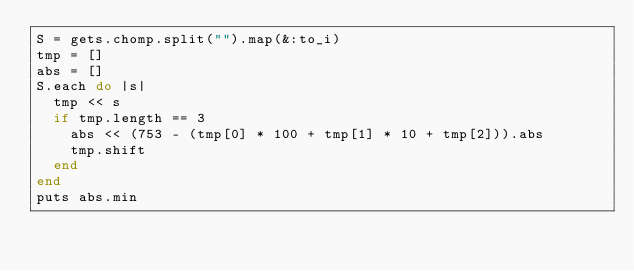Convert code to text. <code><loc_0><loc_0><loc_500><loc_500><_Ruby_>S = gets.chomp.split("").map(&:to_i)
tmp = []
abs = []
S.each do |s|
  tmp << s
  if tmp.length == 3
    abs << (753 - (tmp[0] * 100 + tmp[1] * 10 + tmp[2])).abs
    tmp.shift
  end
end
puts abs.min</code> 